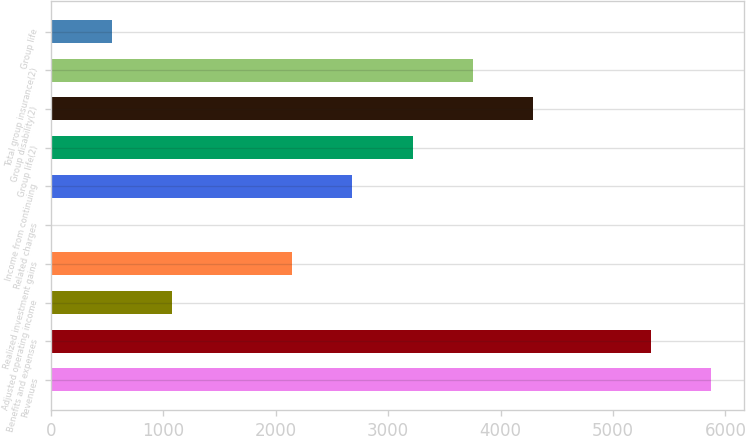<chart> <loc_0><loc_0><loc_500><loc_500><bar_chart><fcel>Revenues<fcel>Benefits and expenses<fcel>Adjusted operating income<fcel>Realized investment gains<fcel>Related charges<fcel>Income from continuing<fcel>Group life(2)<fcel>Group disability(2)<fcel>Total group insurance(2)<fcel>Group life<nl><fcel>5869.2<fcel>5334<fcel>1075.4<fcel>2145.8<fcel>5<fcel>2681<fcel>3216.2<fcel>4286.6<fcel>3751.4<fcel>540.2<nl></chart> 